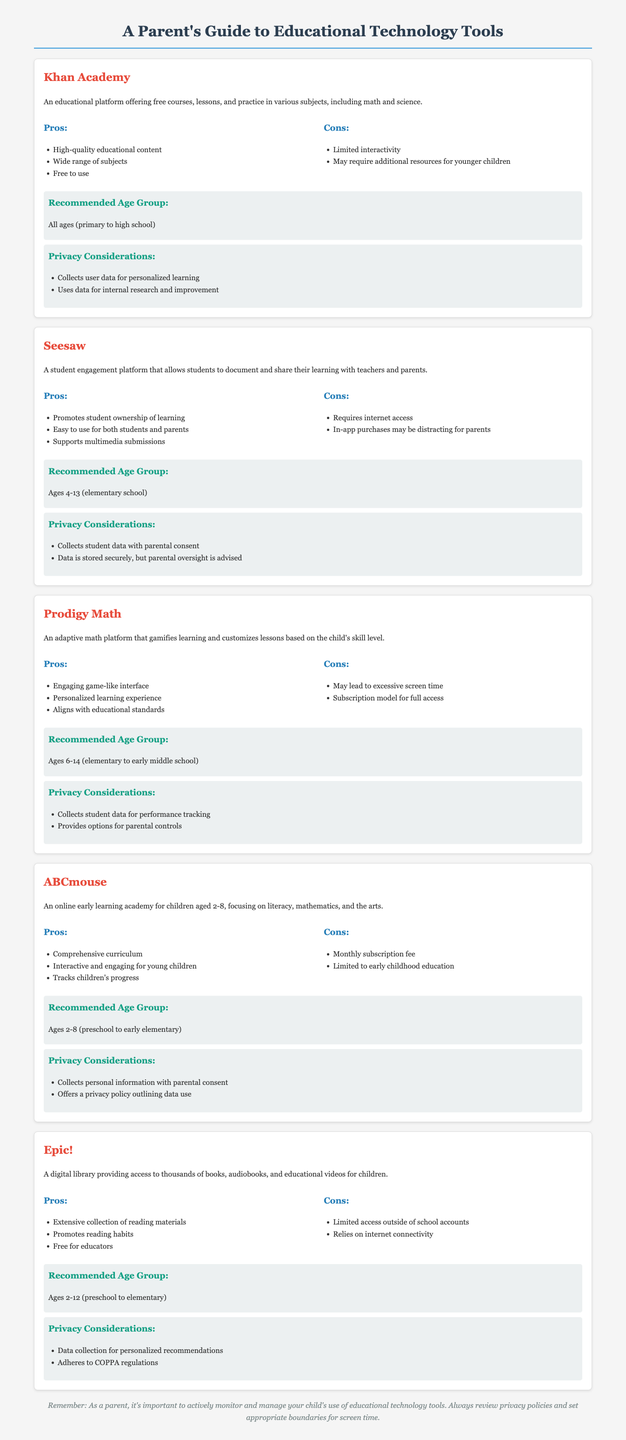What is the primary subject of Khan Academy? The primary subject of Khan Academy includes various subjects, particularly math and science, as it offers free courses.
Answer: math and science What is a significant drawback of using Prodigy Math? A significant drawback of Prodigy Math is that it may lead to excessive screen time, which is noted in its cons.
Answer: excessive screen time What age group is ABCmouse recommended for? ABCmouse is recommended specifically for children aged 2-8.
Answer: Ages 2-8 What does Seesaw promote in terms of student learning? Seesaw promotes student ownership of learning, as mentioned in its pros.
Answer: student ownership of learning How does Epic! restrict access to its materials? Epic! restricts access by limiting it outside of school accounts, as listed in the cons.
Answer: Limited access outside of school accounts What type of interface does Prodigy Math utilize? Prodigy Math utilizes a game-like interface, which enhances engagement according to its pros.
Answer: game-like interface What privacy regulation does Epic! adhere to? Epic! adheres to COPPA regulations, which are specified in its privacy considerations.
Answer: COPPA regulations What is a key benefit of using Khan Academy? A key benefit of Khan Academy is that it provides high-quality educational content, highlighted in its pros.
Answer: High-quality educational content What personal data requirement does ABCmouse have? ABCmouse collects personal information with parental consent, as noted in its privacy considerations.
Answer: parental consent 